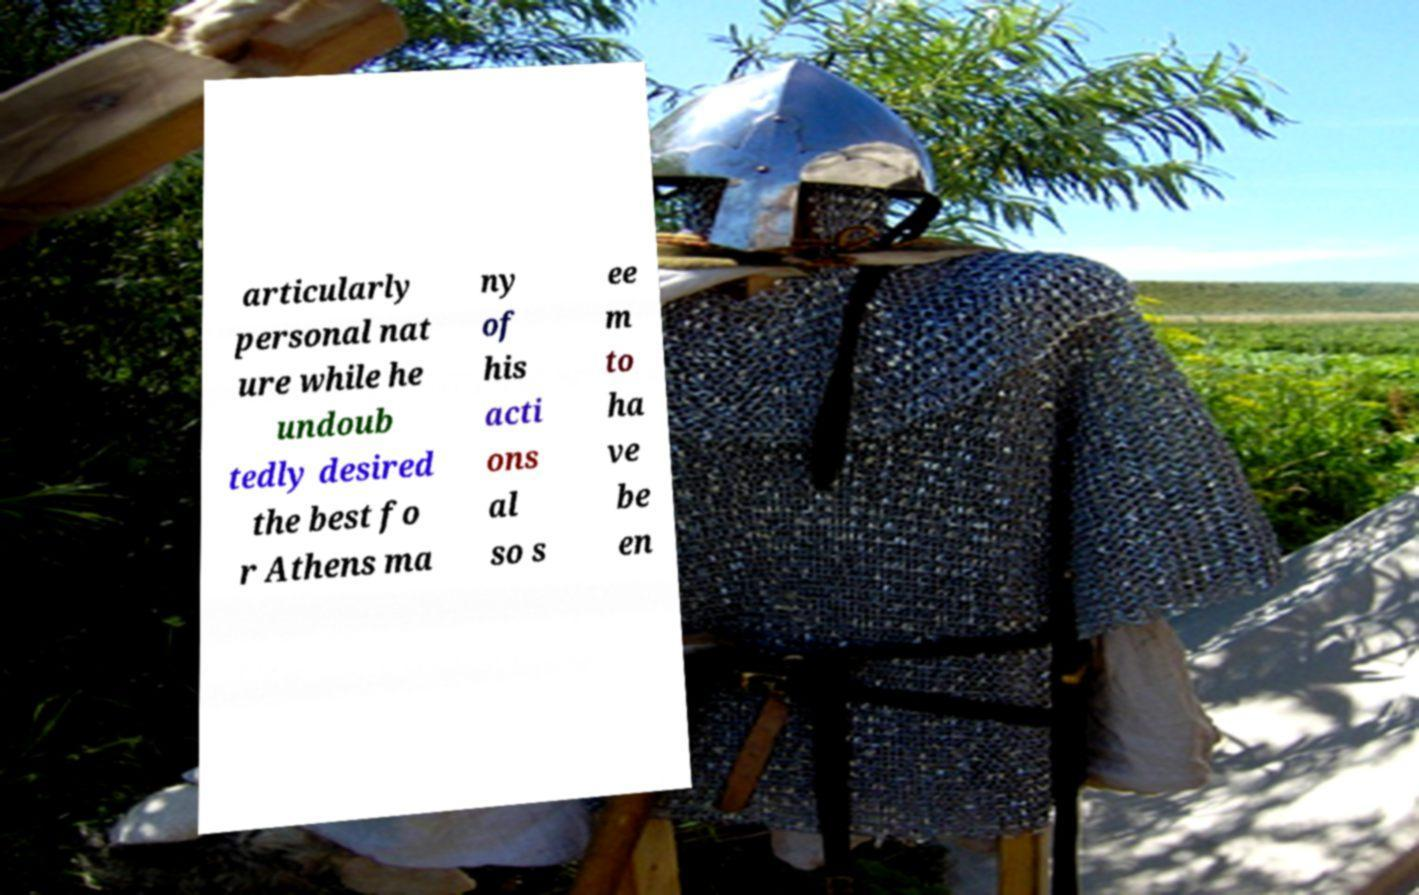I need the written content from this picture converted into text. Can you do that? articularly personal nat ure while he undoub tedly desired the best fo r Athens ma ny of his acti ons al so s ee m to ha ve be en 